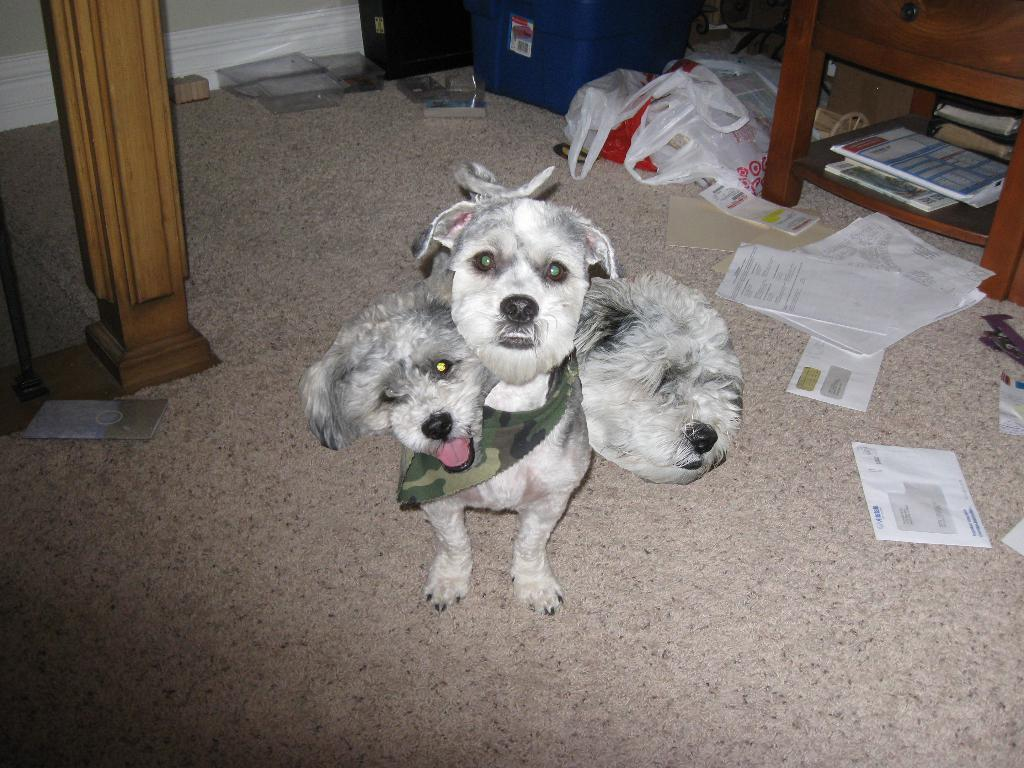What type of animal can be seen in the picture? There is a dog in the picture. What items related to reading or writing are present in the picture? There are papers and books in the picture. Can you describe any other objects or elements in the picture? There are other unspecified things in the picture. How many rings are visible on the dog's tail in the picture? There are no rings visible on the dog's tail in the picture, as the provided facts do not mention any rings. 